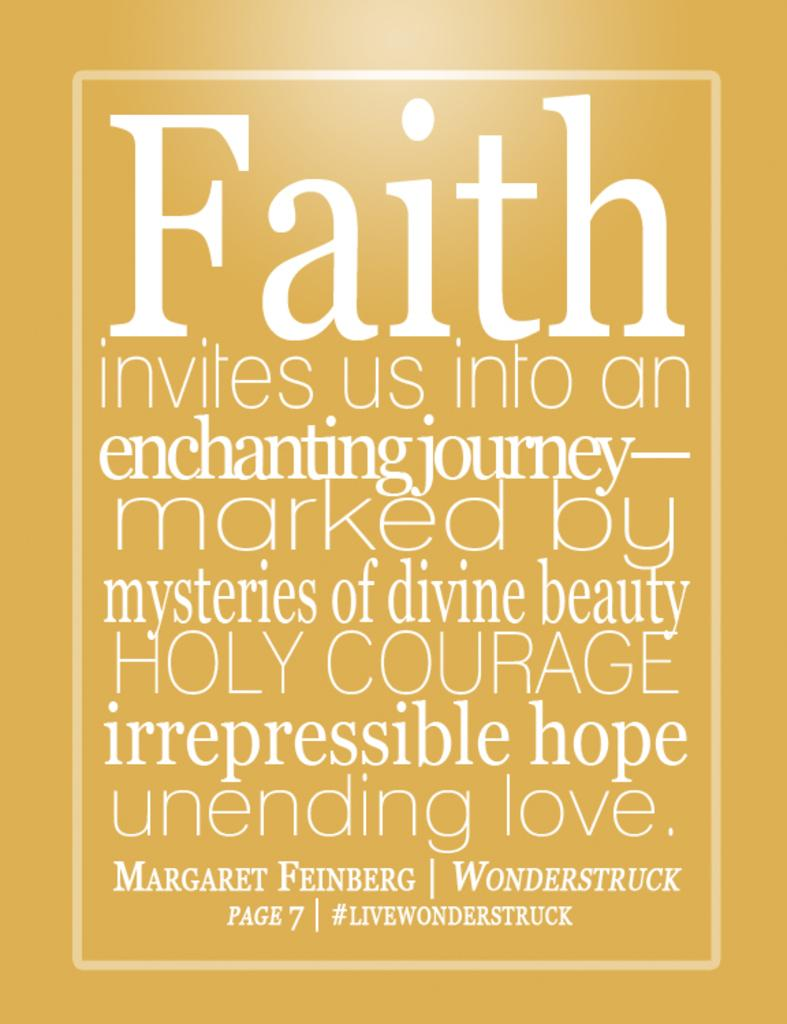What can be found in the image that contains written information? There is text in the image. What type of mailbox can be seen in the image? There is no mailbox present in the image. What is the mind doing in the image? The mind is not a physical object that can be seen in the image. 